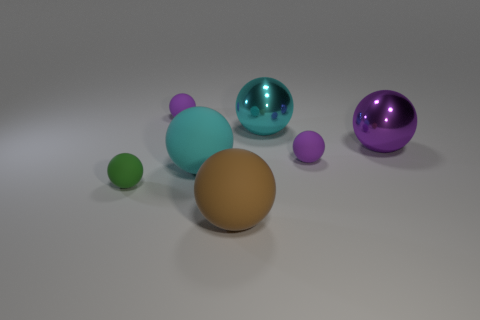What number of objects are large cyan metal objects to the right of the small green object or small purple rubber spheres?
Offer a terse response. 3. There is a large cyan metallic object that is to the left of the purple shiny object that is on the right side of the tiny green rubber sphere; what shape is it?
Give a very brief answer. Sphere. Does the purple metallic sphere have the same size as the rubber sphere in front of the green thing?
Your answer should be compact. Yes. There is a small thing behind the cyan shiny ball; what is its material?
Offer a very short reply. Rubber. How many things are left of the brown ball and behind the green sphere?
Provide a succinct answer. 2. There is a brown object that is the same size as the purple metal object; what is it made of?
Keep it short and to the point. Rubber. There is a object that is in front of the small green sphere; is it the same size as the cyan thing that is on the right side of the brown matte thing?
Make the answer very short. Yes. Are there any big matte balls in front of the green object?
Make the answer very short. Yes. What is the color of the big ball that is to the left of the rubber object that is in front of the small green object?
Offer a very short reply. Cyan. Is the number of small spheres less than the number of rubber spheres?
Your answer should be very brief. Yes. 